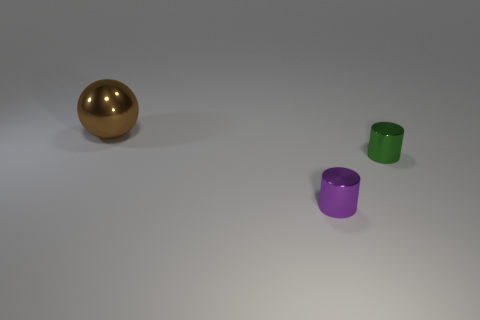Are there any other things that have the same size as the purple cylinder?
Provide a succinct answer. Yes. There is a large object that is the same material as the purple cylinder; what color is it?
Offer a very short reply. Brown. There is a tiny thing that is behind the tiny purple cylinder; what is its color?
Your answer should be compact. Green. Is the number of tiny green objects that are behind the large thing less than the number of brown spheres that are in front of the tiny green cylinder?
Ensure brevity in your answer.  No. There is a purple thing; how many brown metal objects are behind it?
Keep it short and to the point. 1. Are there any small yellow objects that have the same material as the green cylinder?
Provide a succinct answer. No. Is the number of green things in front of the tiny purple cylinder greater than the number of big balls right of the sphere?
Give a very brief answer. No. The green thing has what size?
Your answer should be very brief. Small. There is a metal object that is in front of the small green metallic object; what shape is it?
Provide a succinct answer. Cylinder. Is the large object the same shape as the small green metallic object?
Your answer should be very brief. No. 